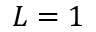Convert formula to latex. <formula><loc_0><loc_0><loc_500><loc_500>L = 1</formula> 